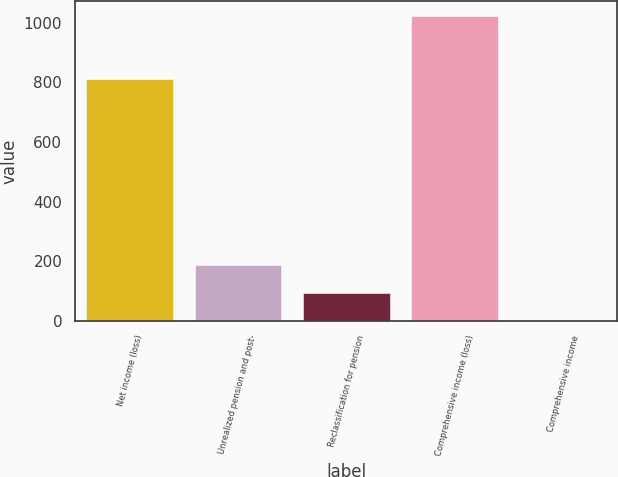Convert chart. <chart><loc_0><loc_0><loc_500><loc_500><bar_chart><fcel>Net income (loss)<fcel>Unrealized pension and post-<fcel>Reclassification for pension<fcel>Comprehensive income (loss)<fcel>Comprehensive income<nl><fcel>811.8<fcel>186.18<fcel>93.34<fcel>1021.24<fcel>0.5<nl></chart> 